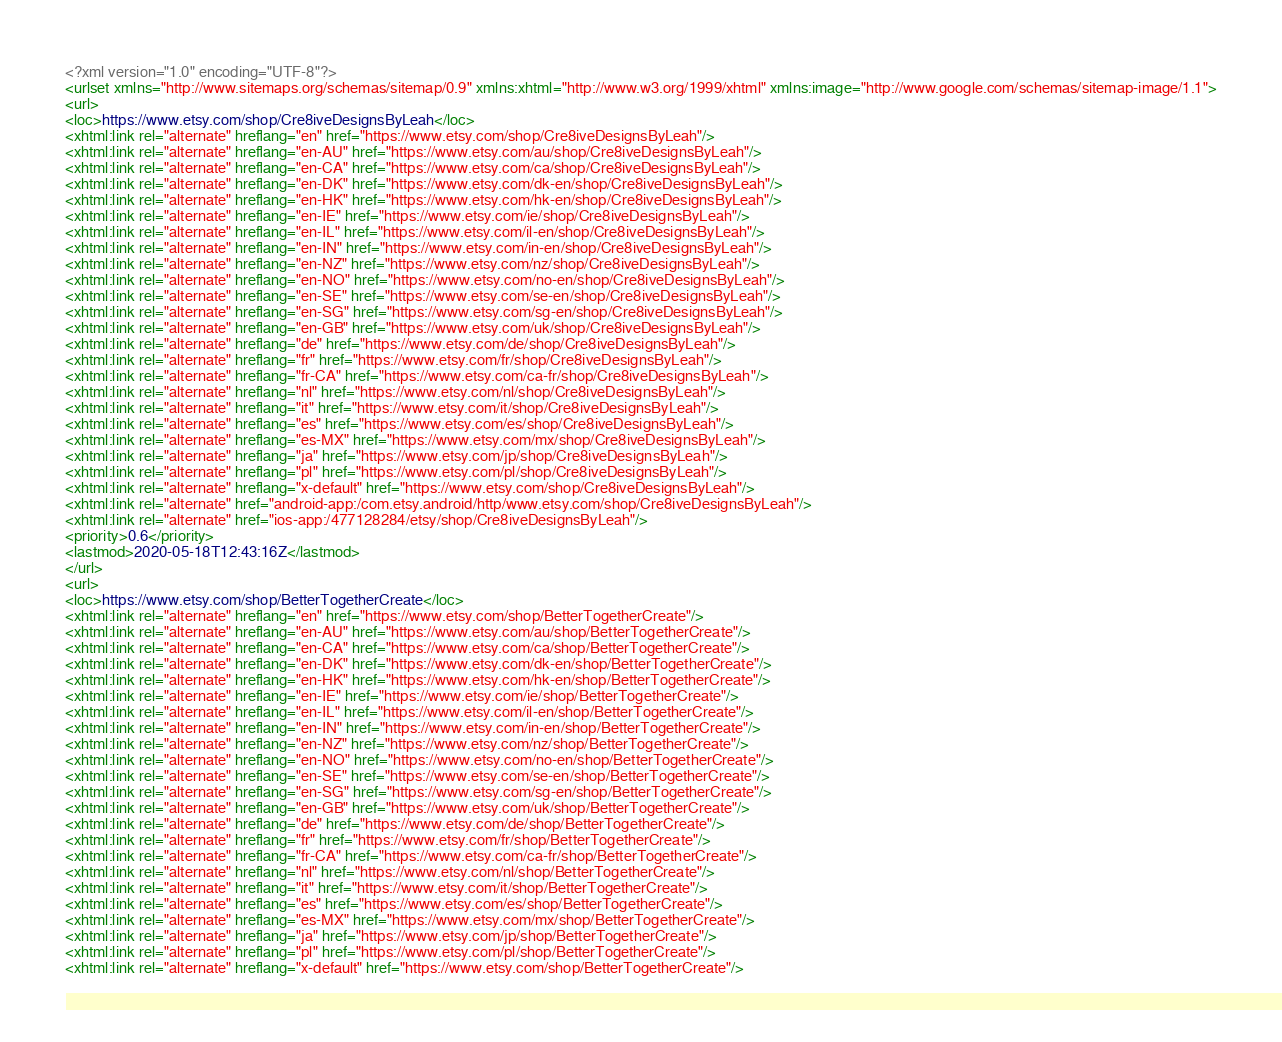Convert code to text. <code><loc_0><loc_0><loc_500><loc_500><_XML_><?xml version="1.0" encoding="UTF-8"?>
<urlset xmlns="http://www.sitemaps.org/schemas/sitemap/0.9" xmlns:xhtml="http://www.w3.org/1999/xhtml" xmlns:image="http://www.google.com/schemas/sitemap-image/1.1">
<url>
<loc>https://www.etsy.com/shop/Cre8iveDesignsByLeah</loc>
<xhtml:link rel="alternate" hreflang="en" href="https://www.etsy.com/shop/Cre8iveDesignsByLeah"/>
<xhtml:link rel="alternate" hreflang="en-AU" href="https://www.etsy.com/au/shop/Cre8iveDesignsByLeah"/>
<xhtml:link rel="alternate" hreflang="en-CA" href="https://www.etsy.com/ca/shop/Cre8iveDesignsByLeah"/>
<xhtml:link rel="alternate" hreflang="en-DK" href="https://www.etsy.com/dk-en/shop/Cre8iveDesignsByLeah"/>
<xhtml:link rel="alternate" hreflang="en-HK" href="https://www.etsy.com/hk-en/shop/Cre8iveDesignsByLeah"/>
<xhtml:link rel="alternate" hreflang="en-IE" href="https://www.etsy.com/ie/shop/Cre8iveDesignsByLeah"/>
<xhtml:link rel="alternate" hreflang="en-IL" href="https://www.etsy.com/il-en/shop/Cre8iveDesignsByLeah"/>
<xhtml:link rel="alternate" hreflang="en-IN" href="https://www.etsy.com/in-en/shop/Cre8iveDesignsByLeah"/>
<xhtml:link rel="alternate" hreflang="en-NZ" href="https://www.etsy.com/nz/shop/Cre8iveDesignsByLeah"/>
<xhtml:link rel="alternate" hreflang="en-NO" href="https://www.etsy.com/no-en/shop/Cre8iveDesignsByLeah"/>
<xhtml:link rel="alternate" hreflang="en-SE" href="https://www.etsy.com/se-en/shop/Cre8iveDesignsByLeah"/>
<xhtml:link rel="alternate" hreflang="en-SG" href="https://www.etsy.com/sg-en/shop/Cre8iveDesignsByLeah"/>
<xhtml:link rel="alternate" hreflang="en-GB" href="https://www.etsy.com/uk/shop/Cre8iveDesignsByLeah"/>
<xhtml:link rel="alternate" hreflang="de" href="https://www.etsy.com/de/shop/Cre8iveDesignsByLeah"/>
<xhtml:link rel="alternate" hreflang="fr" href="https://www.etsy.com/fr/shop/Cre8iveDesignsByLeah"/>
<xhtml:link rel="alternate" hreflang="fr-CA" href="https://www.etsy.com/ca-fr/shop/Cre8iveDesignsByLeah"/>
<xhtml:link rel="alternate" hreflang="nl" href="https://www.etsy.com/nl/shop/Cre8iveDesignsByLeah"/>
<xhtml:link rel="alternate" hreflang="it" href="https://www.etsy.com/it/shop/Cre8iveDesignsByLeah"/>
<xhtml:link rel="alternate" hreflang="es" href="https://www.etsy.com/es/shop/Cre8iveDesignsByLeah"/>
<xhtml:link rel="alternate" hreflang="es-MX" href="https://www.etsy.com/mx/shop/Cre8iveDesignsByLeah"/>
<xhtml:link rel="alternate" hreflang="ja" href="https://www.etsy.com/jp/shop/Cre8iveDesignsByLeah"/>
<xhtml:link rel="alternate" hreflang="pl" href="https://www.etsy.com/pl/shop/Cre8iveDesignsByLeah"/>
<xhtml:link rel="alternate" hreflang="x-default" href="https://www.etsy.com/shop/Cre8iveDesignsByLeah"/>
<xhtml:link rel="alternate" href="android-app:/com.etsy.android/http/www.etsy.com/shop/Cre8iveDesignsByLeah"/>
<xhtml:link rel="alternate" href="ios-app:/477128284/etsy/shop/Cre8iveDesignsByLeah"/>
<priority>0.6</priority>
<lastmod>2020-05-18T12:43:16Z</lastmod>
</url>
<url>
<loc>https://www.etsy.com/shop/BetterTogetherCreate</loc>
<xhtml:link rel="alternate" hreflang="en" href="https://www.etsy.com/shop/BetterTogetherCreate"/>
<xhtml:link rel="alternate" hreflang="en-AU" href="https://www.etsy.com/au/shop/BetterTogetherCreate"/>
<xhtml:link rel="alternate" hreflang="en-CA" href="https://www.etsy.com/ca/shop/BetterTogetherCreate"/>
<xhtml:link rel="alternate" hreflang="en-DK" href="https://www.etsy.com/dk-en/shop/BetterTogetherCreate"/>
<xhtml:link rel="alternate" hreflang="en-HK" href="https://www.etsy.com/hk-en/shop/BetterTogetherCreate"/>
<xhtml:link rel="alternate" hreflang="en-IE" href="https://www.etsy.com/ie/shop/BetterTogetherCreate"/>
<xhtml:link rel="alternate" hreflang="en-IL" href="https://www.etsy.com/il-en/shop/BetterTogetherCreate"/>
<xhtml:link rel="alternate" hreflang="en-IN" href="https://www.etsy.com/in-en/shop/BetterTogetherCreate"/>
<xhtml:link rel="alternate" hreflang="en-NZ" href="https://www.etsy.com/nz/shop/BetterTogetherCreate"/>
<xhtml:link rel="alternate" hreflang="en-NO" href="https://www.etsy.com/no-en/shop/BetterTogetherCreate"/>
<xhtml:link rel="alternate" hreflang="en-SE" href="https://www.etsy.com/se-en/shop/BetterTogetherCreate"/>
<xhtml:link rel="alternate" hreflang="en-SG" href="https://www.etsy.com/sg-en/shop/BetterTogetherCreate"/>
<xhtml:link rel="alternate" hreflang="en-GB" href="https://www.etsy.com/uk/shop/BetterTogetherCreate"/>
<xhtml:link rel="alternate" hreflang="de" href="https://www.etsy.com/de/shop/BetterTogetherCreate"/>
<xhtml:link rel="alternate" hreflang="fr" href="https://www.etsy.com/fr/shop/BetterTogetherCreate"/>
<xhtml:link rel="alternate" hreflang="fr-CA" href="https://www.etsy.com/ca-fr/shop/BetterTogetherCreate"/>
<xhtml:link rel="alternate" hreflang="nl" href="https://www.etsy.com/nl/shop/BetterTogetherCreate"/>
<xhtml:link rel="alternate" hreflang="it" href="https://www.etsy.com/it/shop/BetterTogetherCreate"/>
<xhtml:link rel="alternate" hreflang="es" href="https://www.etsy.com/es/shop/BetterTogetherCreate"/>
<xhtml:link rel="alternate" hreflang="es-MX" href="https://www.etsy.com/mx/shop/BetterTogetherCreate"/>
<xhtml:link rel="alternate" hreflang="ja" href="https://www.etsy.com/jp/shop/BetterTogetherCreate"/>
<xhtml:link rel="alternate" hreflang="pl" href="https://www.etsy.com/pl/shop/BetterTogetherCreate"/>
<xhtml:link rel="alternate" hreflang="x-default" href="https://www.etsy.com/shop/BetterTogetherCreate"/></code> 